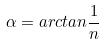Convert formula to latex. <formula><loc_0><loc_0><loc_500><loc_500>\alpha = a r c t a n \frac { 1 } { n }</formula> 